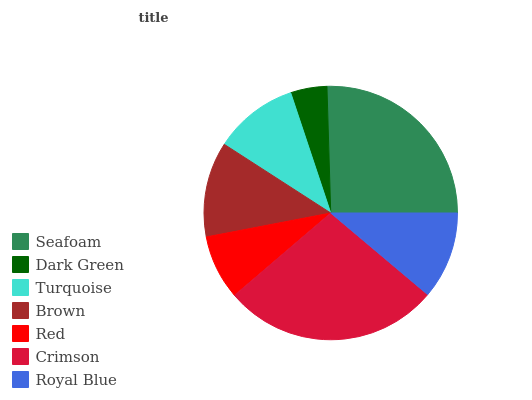Is Dark Green the minimum?
Answer yes or no. Yes. Is Crimson the maximum?
Answer yes or no. Yes. Is Turquoise the minimum?
Answer yes or no. No. Is Turquoise the maximum?
Answer yes or no. No. Is Turquoise greater than Dark Green?
Answer yes or no. Yes. Is Dark Green less than Turquoise?
Answer yes or no. Yes. Is Dark Green greater than Turquoise?
Answer yes or no. No. Is Turquoise less than Dark Green?
Answer yes or no. No. Is Royal Blue the high median?
Answer yes or no. Yes. Is Royal Blue the low median?
Answer yes or no. Yes. Is Turquoise the high median?
Answer yes or no. No. Is Seafoam the low median?
Answer yes or no. No. 